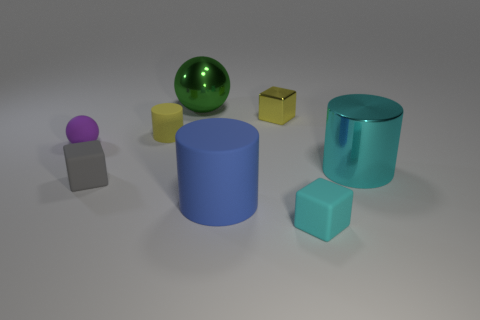Add 2 red blocks. How many objects exist? 10 Subtract all yellow cylinders. How many cylinders are left? 2 Subtract all balls. How many objects are left? 6 Subtract all yellow blocks. How many blocks are left? 2 Add 1 large metallic spheres. How many large metallic spheres exist? 2 Subtract 1 cyan cubes. How many objects are left? 7 Subtract 1 balls. How many balls are left? 1 Subtract all red blocks. Subtract all gray cylinders. How many blocks are left? 3 Subtract all cyan cylinders. How many brown balls are left? 0 Subtract all small purple matte cylinders. Subtract all small matte cubes. How many objects are left? 6 